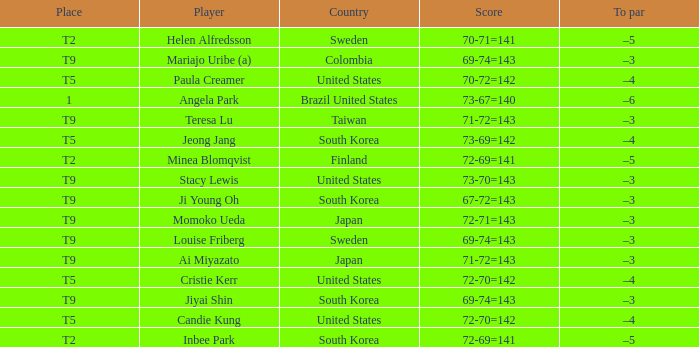Who placed t5 and had a score of 70-72=142? Paula Creamer. 